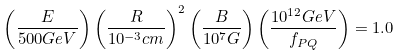Convert formula to latex. <formula><loc_0><loc_0><loc_500><loc_500>\left ( \frac { E } { 5 0 0 G e V } \right ) \left ( \frac { R } { 1 0 ^ { - 3 } c m } \right ) ^ { 2 } \left ( \frac { B } { 1 0 ^ { 7 } G } \right ) \left ( \frac { 1 0 ^ { 1 2 } G e V } { f _ { P Q } } \right ) = 1 . 0</formula> 